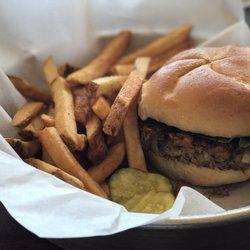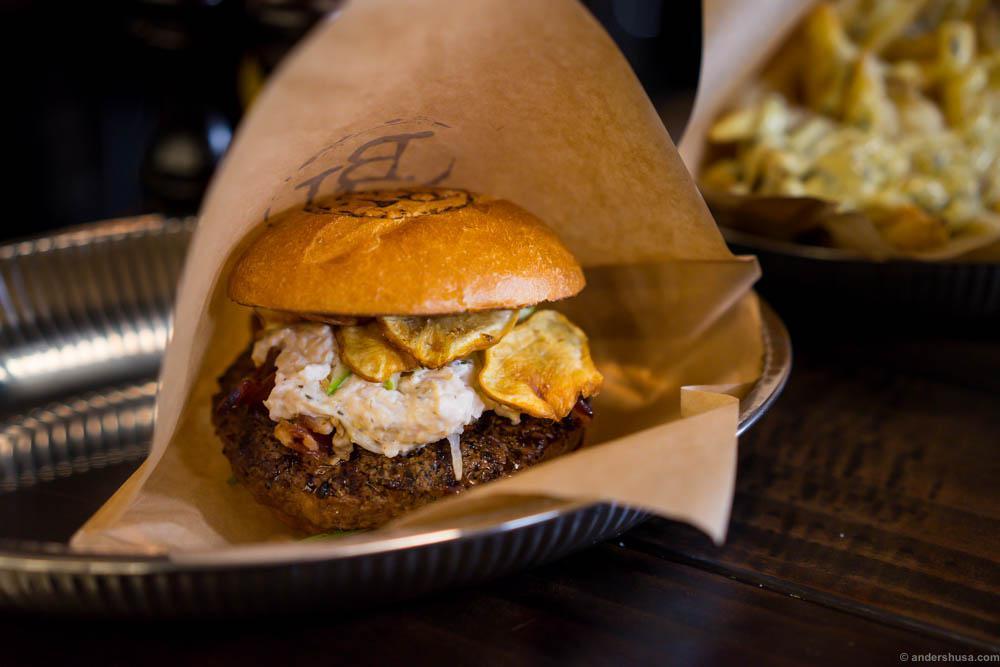The first image is the image on the left, the second image is the image on the right. Examine the images to the left and right. Is the description "There are two burgers sitting on paper." accurate? Answer yes or no. Yes. The first image is the image on the left, the second image is the image on the right. For the images displayed, is the sentence "An image shows a burger next to slender french fries on a white paper in a container." factually correct? Answer yes or no. Yes. 